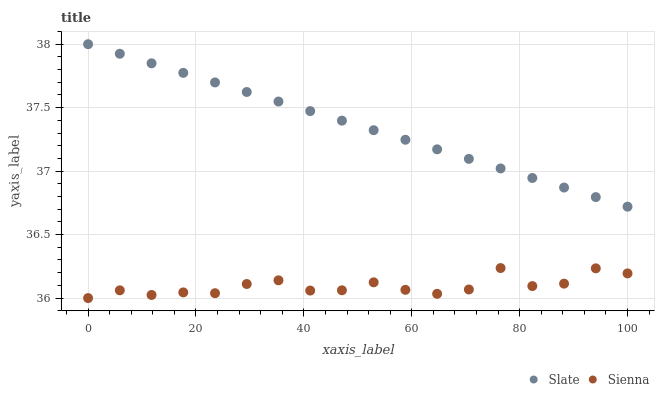Does Sienna have the minimum area under the curve?
Answer yes or no. Yes. Does Slate have the maximum area under the curve?
Answer yes or no. Yes. Does Slate have the minimum area under the curve?
Answer yes or no. No. Is Slate the smoothest?
Answer yes or no. Yes. Is Sienna the roughest?
Answer yes or no. Yes. Is Slate the roughest?
Answer yes or no. No. Does Sienna have the lowest value?
Answer yes or no. Yes. Does Slate have the lowest value?
Answer yes or no. No. Does Slate have the highest value?
Answer yes or no. Yes. Is Sienna less than Slate?
Answer yes or no. Yes. Is Slate greater than Sienna?
Answer yes or no. Yes. Does Sienna intersect Slate?
Answer yes or no. No. 